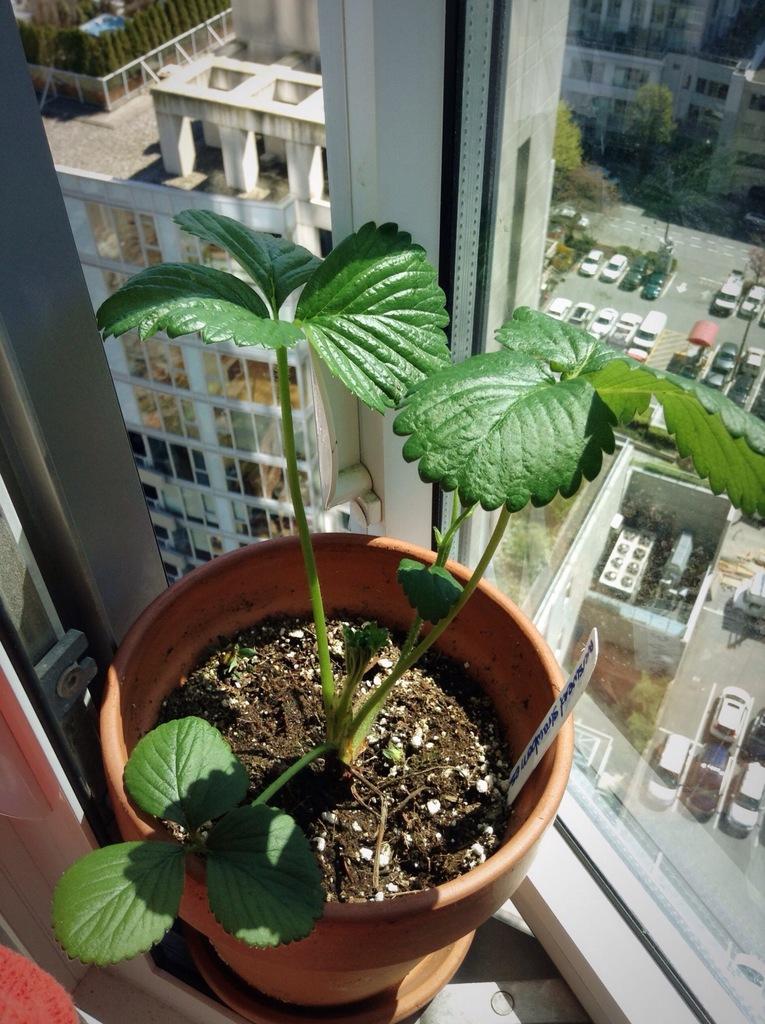How would you summarize this image in a sentence or two? In this image, we can see a pot and there is a window, through the window we can see many vehicles, trees, buildings. 